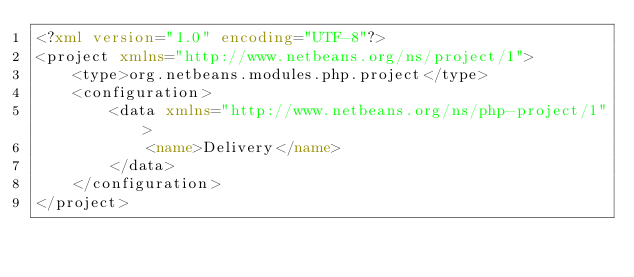<code> <loc_0><loc_0><loc_500><loc_500><_XML_><?xml version="1.0" encoding="UTF-8"?>
<project xmlns="http://www.netbeans.org/ns/project/1">
    <type>org.netbeans.modules.php.project</type>
    <configuration>
        <data xmlns="http://www.netbeans.org/ns/php-project/1">
            <name>Delivery</name>
        </data>
    </configuration>
</project>
</code> 